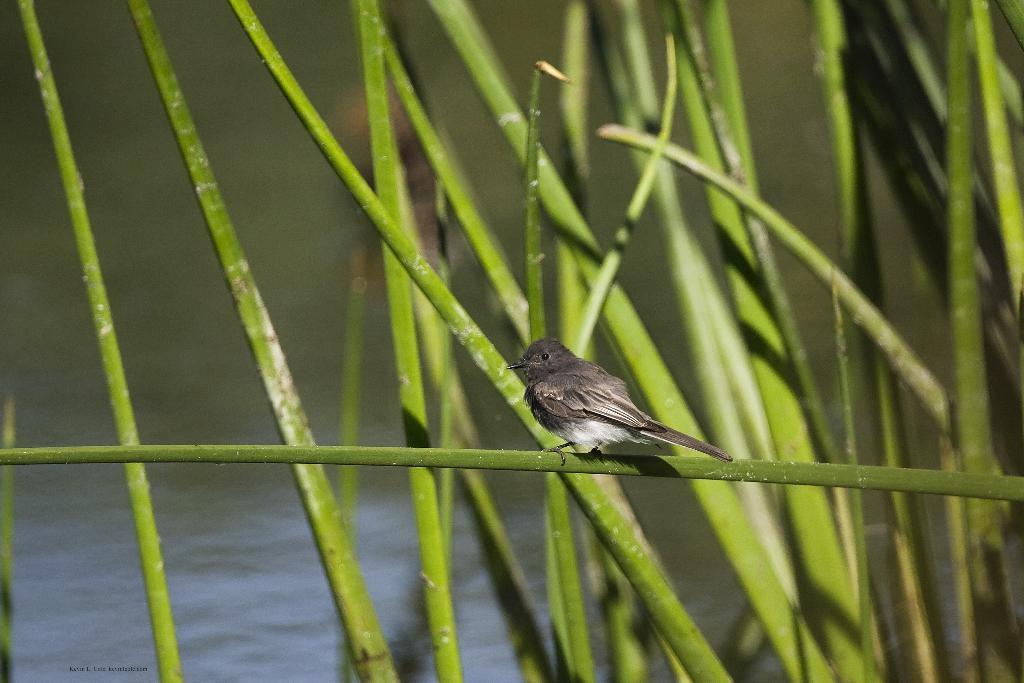Describe this image in one or two sentences. In this image we can see grass and a bird on the grass, in the background there is water. 